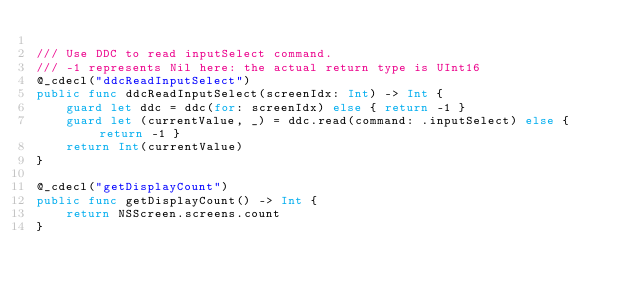Convert code to text. <code><loc_0><loc_0><loc_500><loc_500><_Swift_>
/// Use DDC to read inputSelect command.
/// -1 represents Nil here: the actual return type is UInt16
@_cdecl("ddcReadInputSelect")
public func ddcReadInputSelect(screenIdx: Int) -> Int {
    guard let ddc = ddc(for: screenIdx) else { return -1 }
    guard let (currentValue, _) = ddc.read(command: .inputSelect) else { return -1 }
    return Int(currentValue)
}

@_cdecl("getDisplayCount")
public func getDisplayCount() -> Int {
    return NSScreen.screens.count
}
</code> 